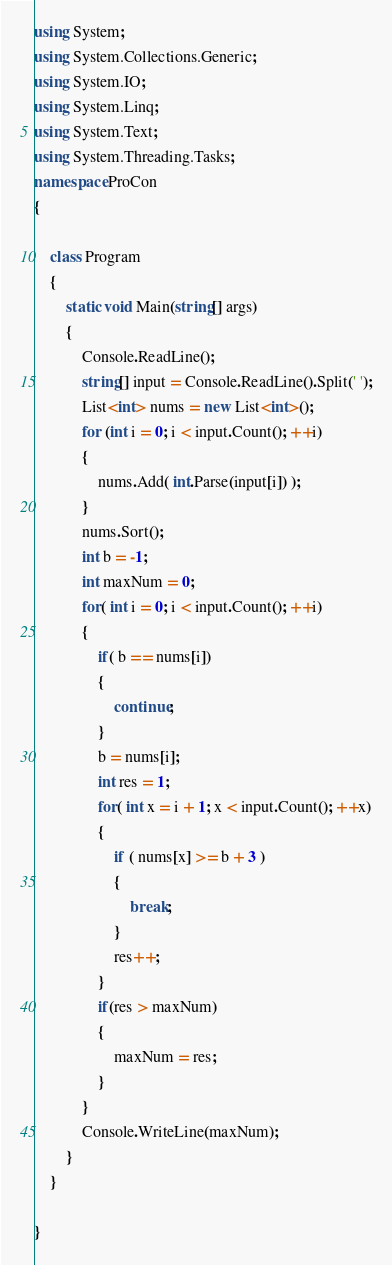<code> <loc_0><loc_0><loc_500><loc_500><_C#_>using System;
using System.Collections.Generic;
using System.IO;
using System.Linq;
using System.Text;
using System.Threading.Tasks;
namespace ProCon
{

    class Program
    {
        static void Main(string[] args)
        {
            Console.ReadLine();
            string[] input = Console.ReadLine().Split(' ');
            List<int> nums = new List<int>();
            for (int i = 0; i < input.Count(); ++i)
            {
                nums.Add( int.Parse(input[i]) );
            }
            nums.Sort();
            int b = -1;
            int maxNum = 0;
            for( int i = 0; i < input.Count(); ++i)
            {
                if( b == nums[i])
                {
                    continue;
                }
                b = nums[i];
                int res = 1;
                for( int x = i + 1; x < input.Count(); ++x)
                {                   
                    if ( nums[x] >= b + 3 )
                    {
                        break;
                    }
                    res++;
                }
                if(res > maxNum)
                {
                    maxNum = res;
                }
            }
            Console.WriteLine(maxNum);
        }
    }

}</code> 